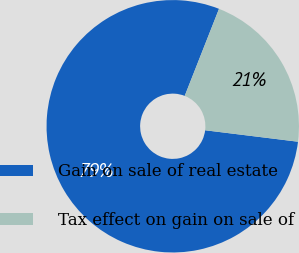Convert chart. <chart><loc_0><loc_0><loc_500><loc_500><pie_chart><fcel>Gain on sale of real estate<fcel>Tax effect on gain on sale of<nl><fcel>79.02%<fcel>20.98%<nl></chart> 